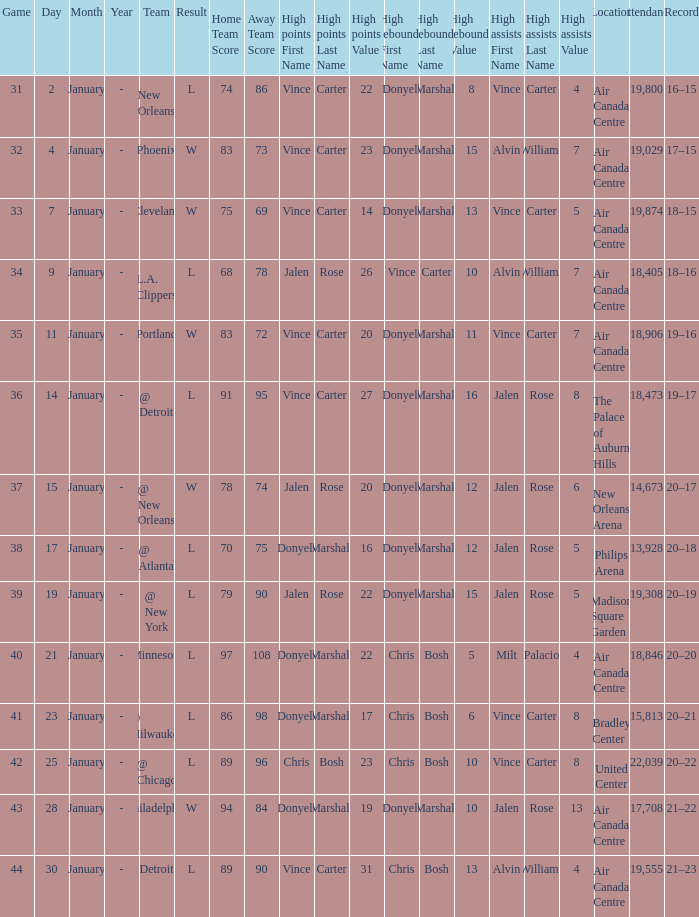Where was the game, and how many attended the game on january 2? Air Canada Centre 19,800. 